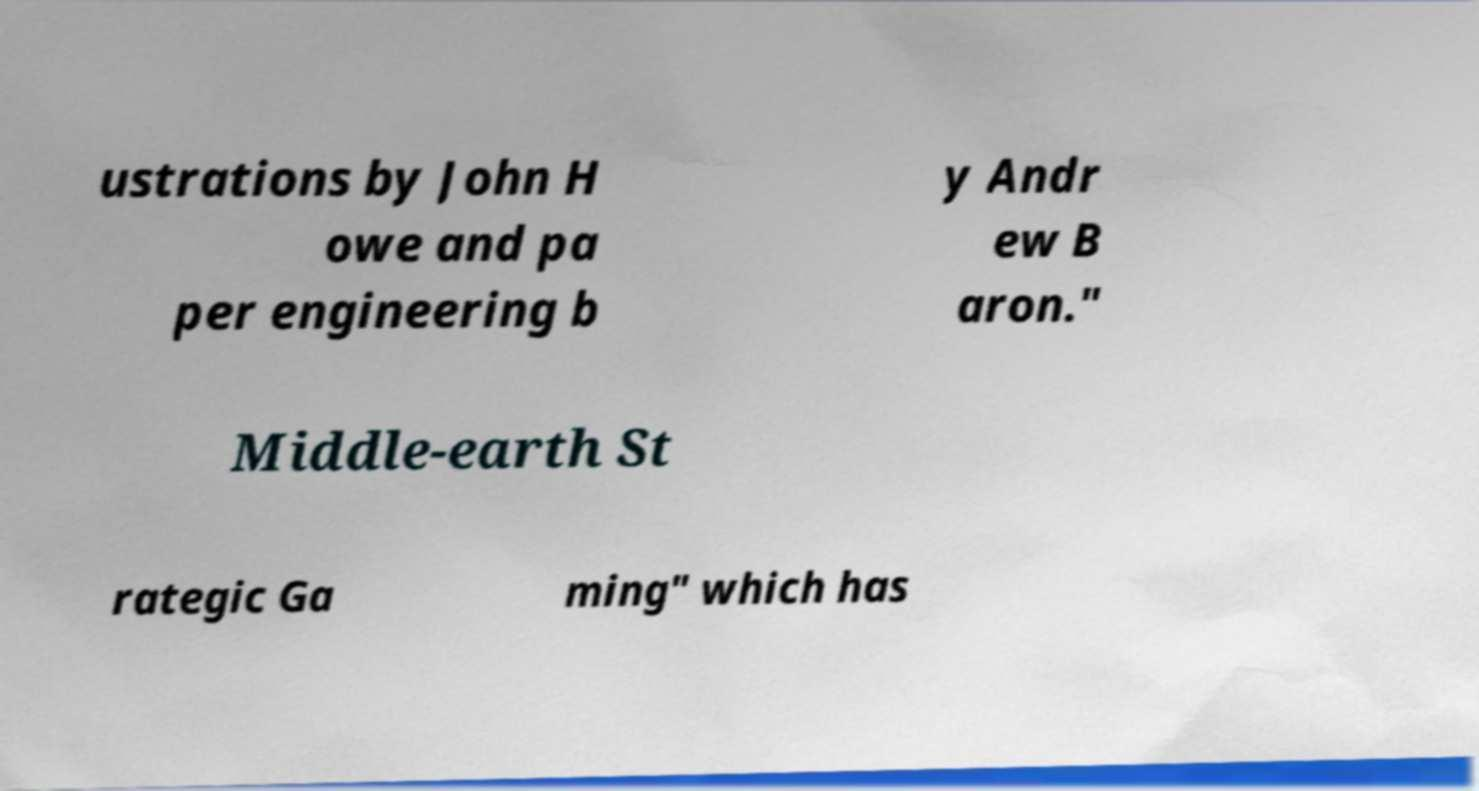Can you read and provide the text displayed in the image?This photo seems to have some interesting text. Can you extract and type it out for me? ustrations by John H owe and pa per engineering b y Andr ew B aron." Middle-earth St rategic Ga ming" which has 